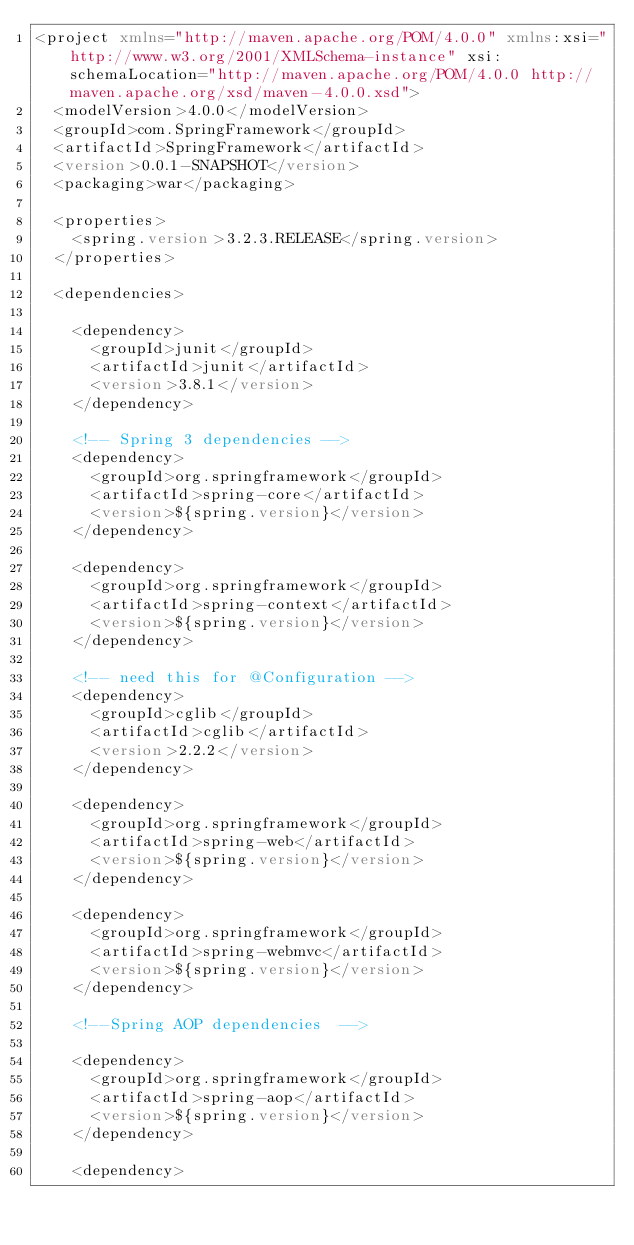<code> <loc_0><loc_0><loc_500><loc_500><_XML_><project xmlns="http://maven.apache.org/POM/4.0.0" xmlns:xsi="http://www.w3.org/2001/XMLSchema-instance" xsi:schemaLocation="http://maven.apache.org/POM/4.0.0 http://maven.apache.org/xsd/maven-4.0.0.xsd">
  <modelVersion>4.0.0</modelVersion>
  <groupId>com.SpringFramework</groupId>
  <artifactId>SpringFramework</artifactId>
  <version>0.0.1-SNAPSHOT</version>
  <packaging>war</packaging>
  
  <properties>
		<spring.version>3.2.3.RELEASE</spring.version>
	</properties>
 
	<dependencies>
	
		<dependency>
			<groupId>junit</groupId>
			<artifactId>junit</artifactId>
			<version>3.8.1</version>
		</dependency>
 
		<!-- Spring 3 dependencies -->
		<dependency>
			<groupId>org.springframework</groupId>
			<artifactId>spring-core</artifactId>
			<version>${spring.version}</version>
		</dependency>
 
		<dependency>
			<groupId>org.springframework</groupId>
			<artifactId>spring-context</artifactId>
			<version>${spring.version}</version>
		</dependency>
		
		<!-- need this for @Configuration -->
		<dependency>
			<groupId>cglib</groupId>
			<artifactId>cglib</artifactId>
			<version>2.2.2</version>
		</dependency>
 
		<dependency>
			<groupId>org.springframework</groupId>
			<artifactId>spring-web</artifactId>
			<version>${spring.version}</version>
		</dependency>
 
		<dependency>
			<groupId>org.springframework</groupId>
			<artifactId>spring-webmvc</artifactId>
			<version>${spring.version}</version>
		</dependency>
		
		<!--Spring AOP dependencies  -->
		
		<dependency>
			<groupId>org.springframework</groupId>
			<artifactId>spring-aop</artifactId>
			<version>${spring.version}</version>
		</dependency>
 
		<dependency></code> 